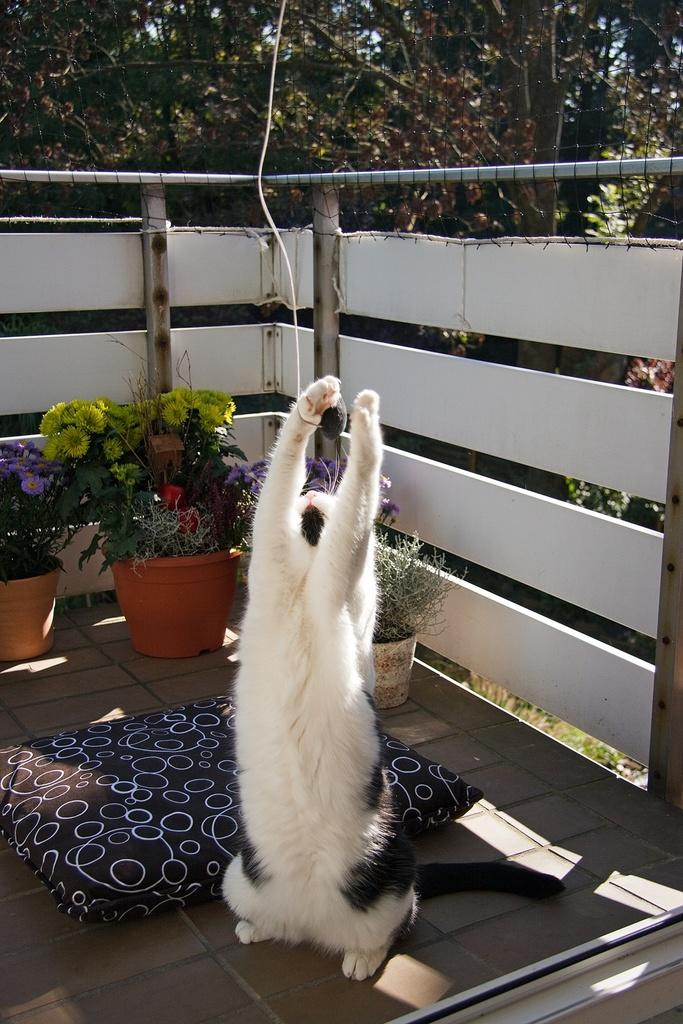What type of animal can be seen in the image? There is a dog in the image. What is located beside the dog? There is a pillow beside the dog. What can be seen on the balcony of the building in the image? There are flower pots on the balcony of a building. What type of barrier is present in the image? There is a fence in the image. What type of natural scenery is visible in the background of the image? There are trees in the background of the image. Can you see a friend of the dog playing in the dirt in the image? There is no friend of the dog playing in the dirt in the image. In fact, there is no dirt visible in the image. 